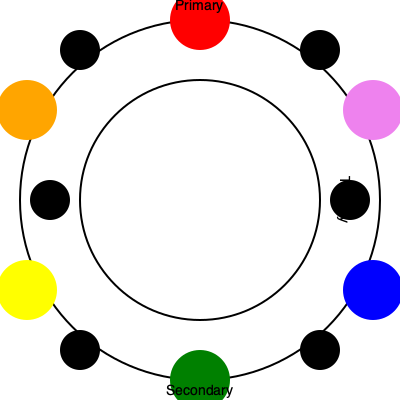In comic art, how would you effectively use complementary colors to create dynamic contrast and visual impact in a panel depicting a high-energy action scene? Refer to the color wheel diagram and provide specific examples of color combinations. To effectively use complementary colors in a high-energy action scene in comic art, follow these steps:

1. Understand complementary colors:
   - Complementary colors are pairs of colors opposite each other on the color wheel.
   - They create maximum contrast and visual impact when used together.

2. Identify complementary pairs from the color wheel:
   - Red and Green
   - Blue and Orange
   - Yellow and Violet

3. Apply complementary colors in the action scene:
   a) Background and foreground contrast:
      - Use one complementary color for the background and its opposite for the foreground elements.
      - Example: Blue background with orange-tinted characters or objects in the foreground.

   b) Character costume design:
      - Design character costumes using complementary colors to make them stand out.
      - Example: A superhero with a red costume against a green environment.

   c) Energy effects and impact lines:
      - Use one color of the complementary pair for the main action and its opposite for energy effects or impact lines.
      - Example: Yellow lightning bolts against a violet sky.

   d) Panel borders and speech bubbles:
      - Incorporate complementary colors in panel borders or speech bubbles to enhance the overall dynamic feel.
      - Example: Red panel borders for a scene with predominantly green tones.

4. Balance color usage:
   - Use the 60-30-10 rule: 60% dominant color, 30% secondary color, and 10% accent color.
   - This ensures the complementary colors enhance rather than overwhelm the scene.

5. Consider color symbolism:
   - Red/Green: Conflict, tension, or nature vs. technology themes.
   - Blue/Orange: Day vs. night, fire vs. ice, or technology vs. nature themes.
   - Yellow/Violet: Light vs. darkness, joy vs. mystery themes.

6. Adjust color intensity:
   - Use pure complementary colors for maximum impact in focal points.
   - Soften or mute colors in less important areas to direct attention.

By applying these principles, you can create visually striking and dynamic action scenes that effectively use color theory to enhance storytelling and emotional impact in comic art.
Answer: Use opposite colors on the wheel for maximum contrast: red/green, blue/orange, or yellow/violet. Apply to background/foreground, character design, energy effects, and panel elements, following the 60-30-10 rule for balance. 